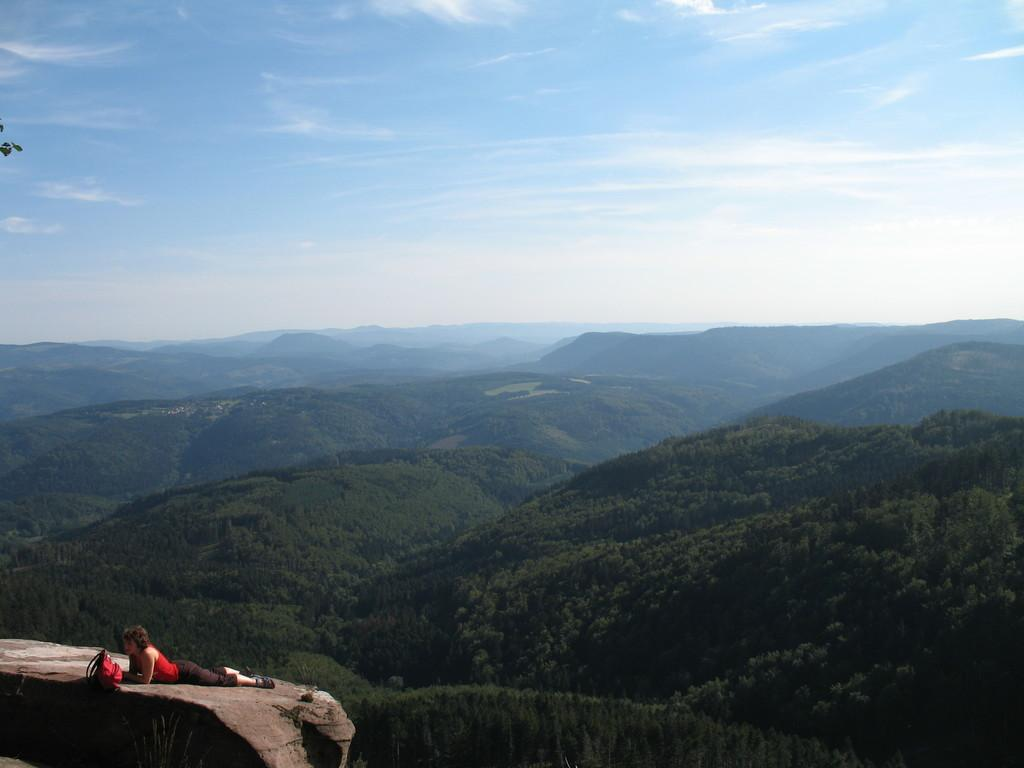What is located in the left bottom corner of the image? There is a rock in the left bottom corner of the image. What is happening on the rock? A lady is lying on the rock. What is the color of the bag on the rock? There is a red bag on the rock. What can be seen in the background of the image? There is sky visible in the background of the image, and there are hills with trees. What type of pest can be seen crawling on the lady's arm in the image? There are no pests visible in the image; it only shows a lady lying on a rock with a red bag. What part of the lady's body is providing advice in the image? There is no indication in the image that any part of the lady's body is providing advice. 